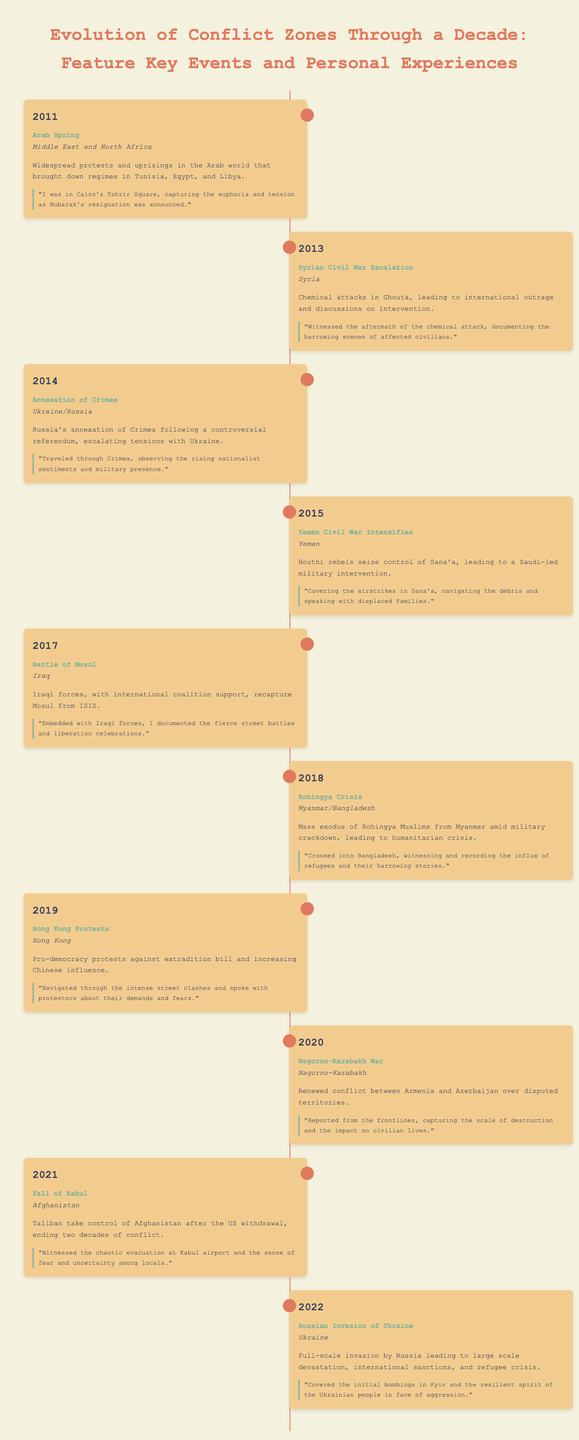What event was marked by widespread protests in 2011? The document mentions the Arab Spring as the key event in 2011 which was characterized by protests and uprisings.
Answer: Arab Spring In which location did the Battle of Mosul occur? According to the timeline, the Battle of Mosul took place in Iraq.
Answer: Iraq What year did the Russian invasion of Ukraine start? The timeline clearly states that the full-scale invasion by Russia occurred in 2022.
Answer: 2022 Which conflict intensified in Yemen in 2015? The document indicates that the Yemen Civil War intensified when Houthi rebels seized control of Sana'a in 2015.
Answer: Yemen Civil War What significant event happened in Afghanistan in 2021? The timeline highlights the Fall of Kabul as a pivotal event in Afghanistan in 2021.
Answer: Fall of Kabul Which year featured the Rohingya Crisis? The timeline specifies that the Rohingya Crisis occurred in 2018.
Answer: 2018 What experience did the reporter have during the protests in Hong Kong? The document describes the reporter's experience of navigating intense street clashes and speaking with protestors.
Answer: Navigated through clashes How many years spanned the timeline from 2011 to 2022? The timeline lists events from 2011 to 2022, which is a total of 12 years.
Answer: 12 years What type of documentation was mentioned during the chemical attacks in Syria? The personal experience documented the harrowing scenes of affected civilians after the chemical attacks.
Answer: Documenting harrowing scenes 